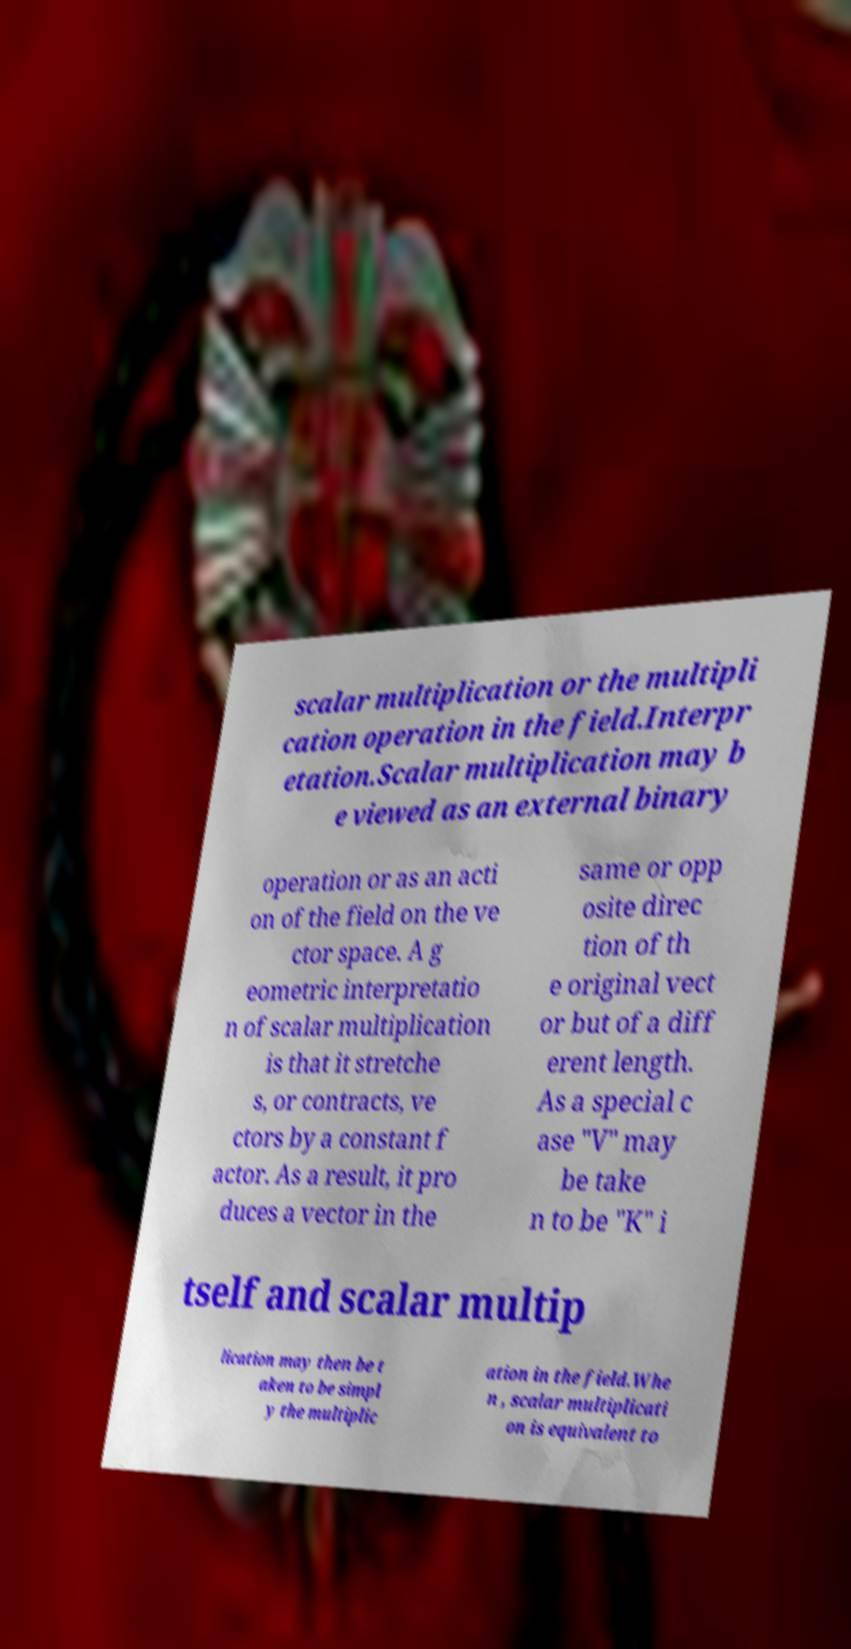Could you assist in decoding the text presented in this image and type it out clearly? scalar multiplication or the multipli cation operation in the field.Interpr etation.Scalar multiplication may b e viewed as an external binary operation or as an acti on of the field on the ve ctor space. A g eometric interpretatio n of scalar multiplication is that it stretche s, or contracts, ve ctors by a constant f actor. As a result, it pro duces a vector in the same or opp osite direc tion of th e original vect or but of a diff erent length. As a special c ase "V" may be take n to be "K" i tself and scalar multip lication may then be t aken to be simpl y the multiplic ation in the field.Whe n , scalar multiplicati on is equivalent to 